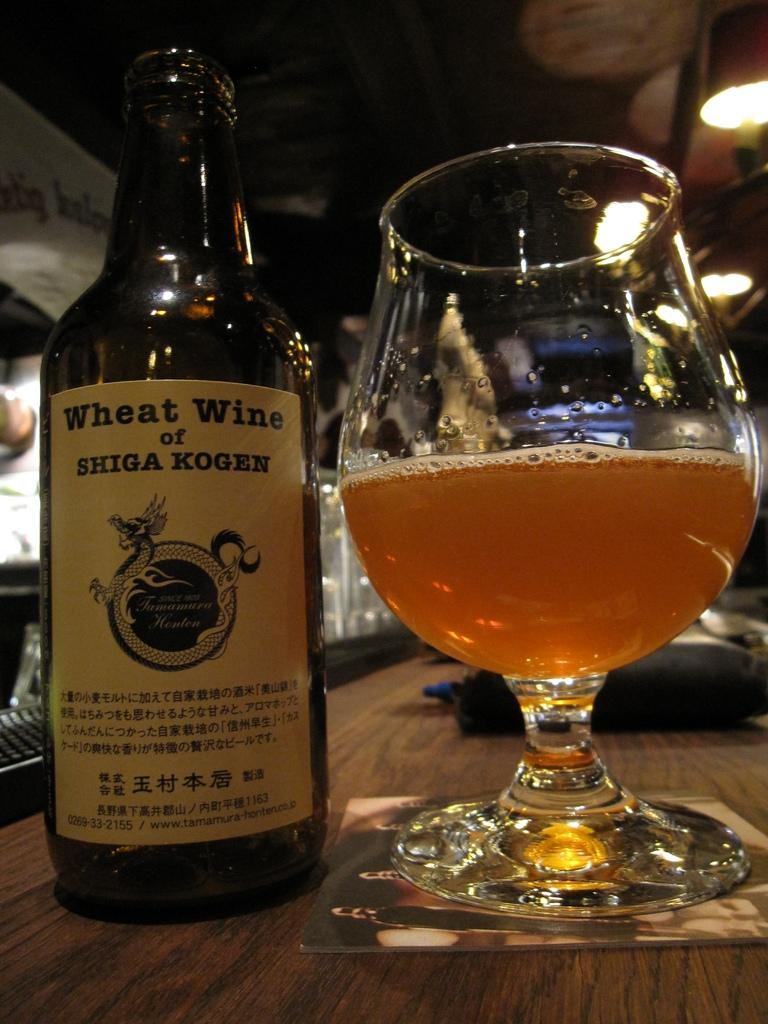<image>
Present a compact description of the photo's key features. Bottle of Wheat wine next to a half cup of beer. 